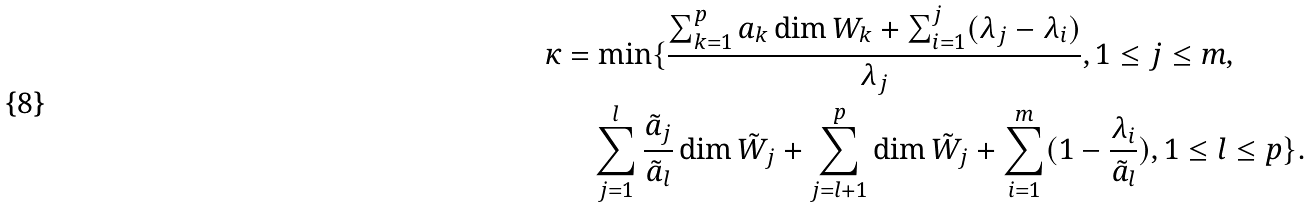Convert formula to latex. <formula><loc_0><loc_0><loc_500><loc_500>\kappa & = \min \{ \frac { \sum _ { k = 1 } ^ { p } a _ { k } \dim W _ { k } + \sum _ { i = 1 } ^ { j } ( \lambda _ { j } - \lambda _ { i } ) } { \lambda _ { j } } , 1 \leq j \leq m , \\ & \quad \sum _ { j = 1 } ^ { l } \frac { \tilde { a } _ { j } } { \tilde { a } _ { l } } \dim \tilde { W } _ { j } + \sum _ { j = l + 1 } ^ { p } \dim \tilde { W } _ { j } + \sum _ { i = 1 } ^ { m } ( 1 - \frac { \lambda _ { i } } { \tilde { a } _ { l } } ) , 1 \leq l \leq p \} .</formula> 